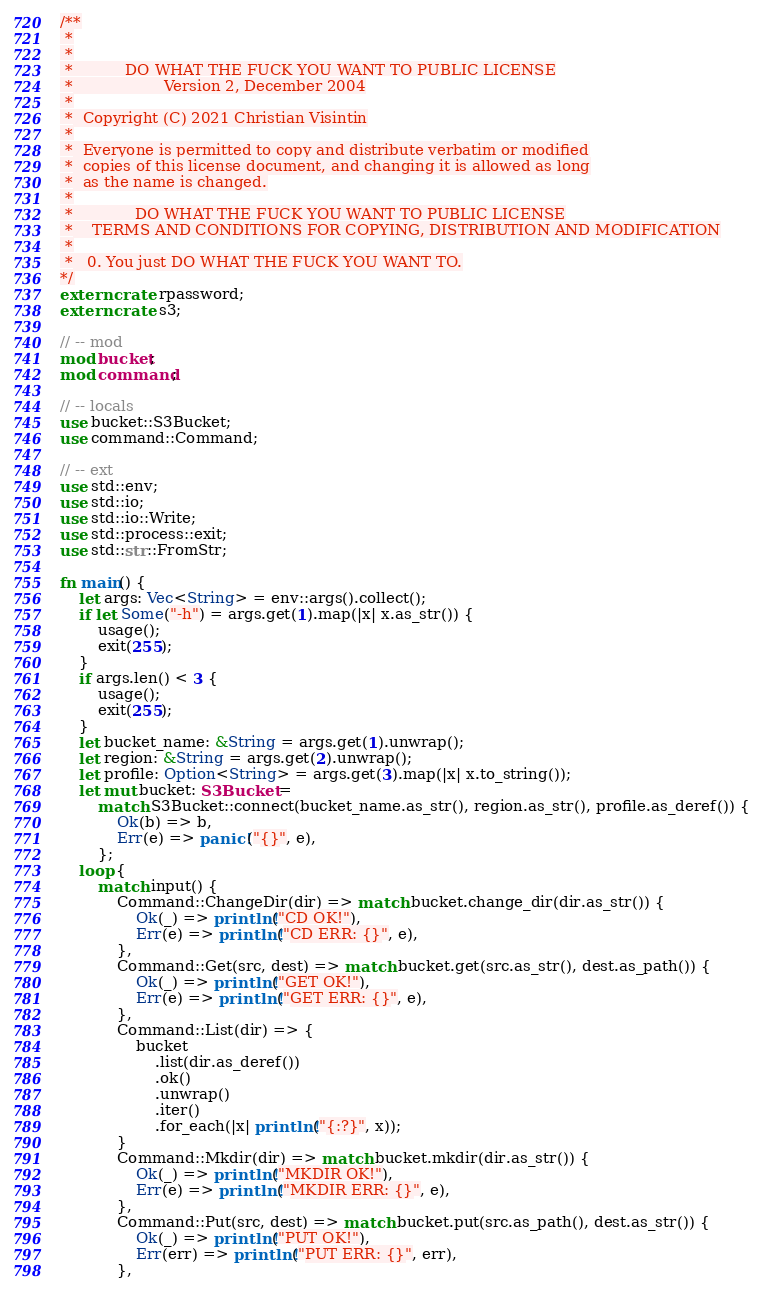Convert code to text. <code><loc_0><loc_0><loc_500><loc_500><_Rust_>/**
 *
 *
 *           DO WHAT THE FUCK YOU WANT TO PUBLIC LICENSE
 *                   Version 2, December 2004
 *
 *  Copyright (C) 2021 Christian Visintin
 *
 *  Everyone is permitted to copy and distribute verbatim or modified
 *  copies of this license document, and changing it is allowed as long
 *  as the name is changed.
 *
 *             DO WHAT THE FUCK YOU WANT TO PUBLIC LICENSE
 *    TERMS AND CONDITIONS FOR COPYING, DISTRIBUTION AND MODIFICATION
 *
 *   0. You just DO WHAT THE FUCK YOU WANT TO.
*/
extern crate rpassword;
extern crate s3;

// -- mod
mod bucket;
mod command;

// -- locals
use bucket::S3Bucket;
use command::Command;

// -- ext
use std::env;
use std::io;
use std::io::Write;
use std::process::exit;
use std::str::FromStr;

fn main() {
    let args: Vec<String> = env::args().collect();
    if let Some("-h") = args.get(1).map(|x| x.as_str()) {
        usage();
        exit(255);
    }
    if args.len() < 3 {
        usage();
        exit(255);
    }
    let bucket_name: &String = args.get(1).unwrap();
    let region: &String = args.get(2).unwrap();
    let profile: Option<String> = args.get(3).map(|x| x.to_string());
    let mut bucket: S3Bucket =
        match S3Bucket::connect(bucket_name.as_str(), region.as_str(), profile.as_deref()) {
            Ok(b) => b,
            Err(e) => panic!("{}", e),
        };
    loop {
        match input() {
            Command::ChangeDir(dir) => match bucket.change_dir(dir.as_str()) {
                Ok(_) => println!("CD OK!"),
                Err(e) => println!("CD ERR: {}", e),
            },
            Command::Get(src, dest) => match bucket.get(src.as_str(), dest.as_path()) {
                Ok(_) => println!("GET OK!"),
                Err(e) => println!("GET ERR: {}", e),
            },
            Command::List(dir) => {
                bucket
                    .list(dir.as_deref())
                    .ok()
                    .unwrap()
                    .iter()
                    .for_each(|x| println!("{:?}", x));
            }
            Command::Mkdir(dir) => match bucket.mkdir(dir.as_str()) {
                Ok(_) => println!("MKDIR OK!"),
                Err(e) => println!("MKDIR ERR: {}", e),
            },
            Command::Put(src, dest) => match bucket.put(src.as_path(), dest.as_str()) {
                Ok(_) => println!("PUT OK!"),
                Err(err) => println!("PUT ERR: {}", err),
            },</code> 